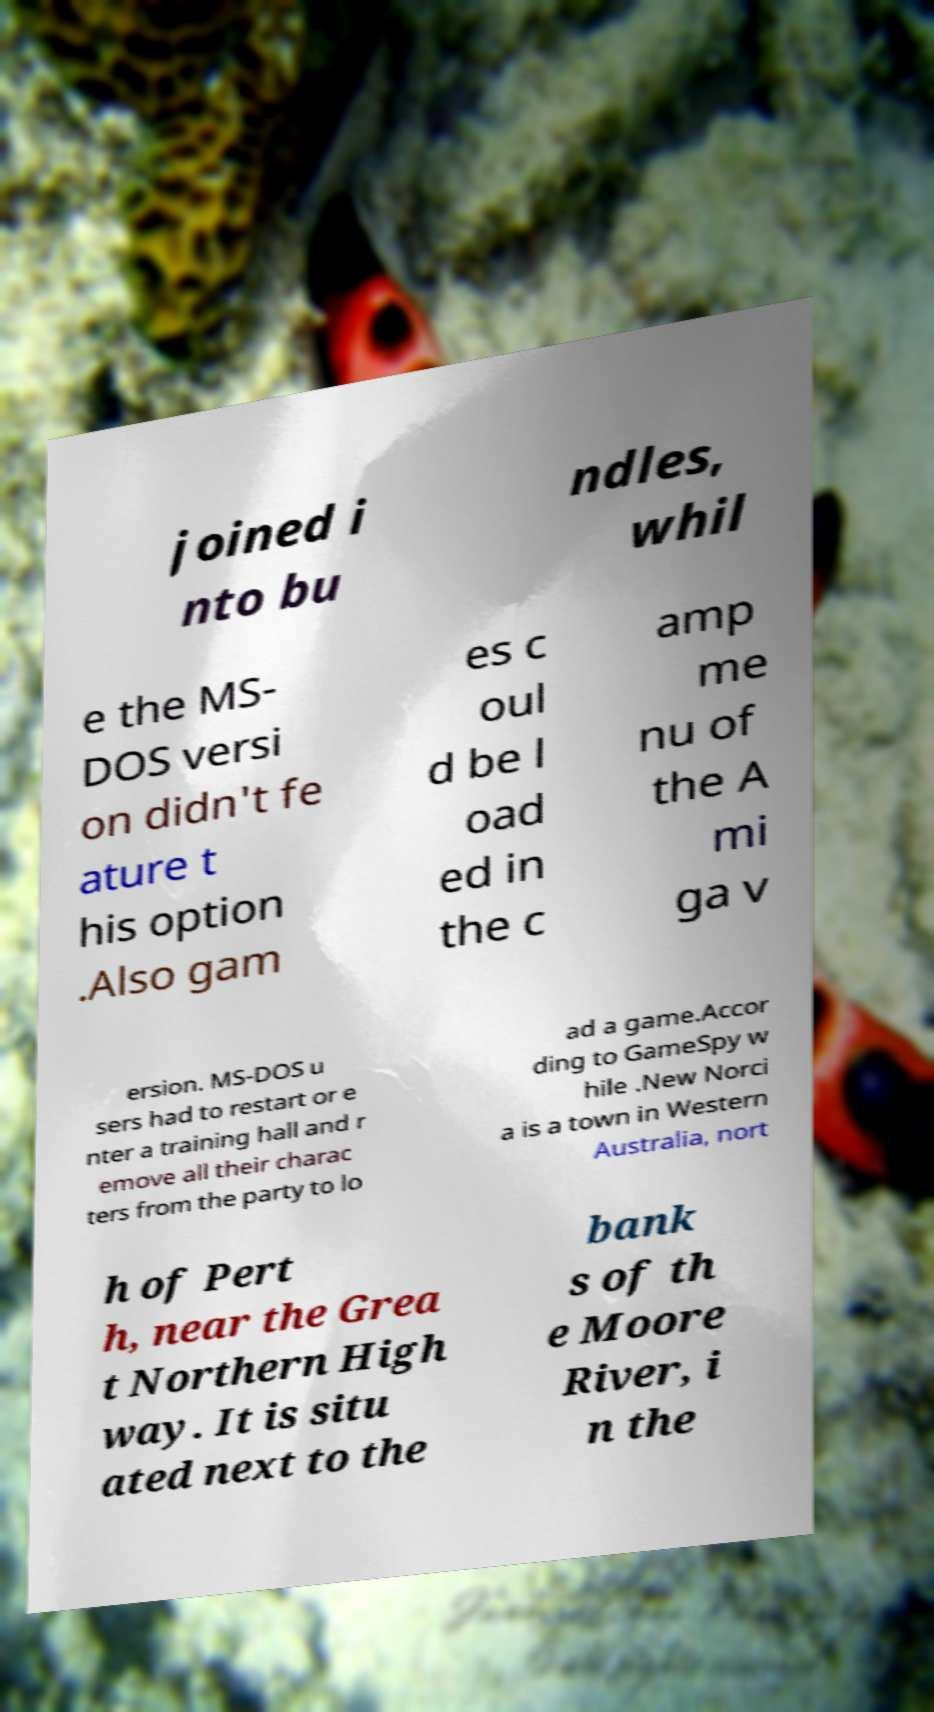Could you assist in decoding the text presented in this image and type it out clearly? joined i nto bu ndles, whil e the MS- DOS versi on didn't fe ature t his option .Also gam es c oul d be l oad ed in the c amp me nu of the A mi ga v ersion. MS-DOS u sers had to restart or e nter a training hall and r emove all their charac ters from the party to lo ad a game.Accor ding to GameSpy w hile .New Norci a is a town in Western Australia, nort h of Pert h, near the Grea t Northern High way. It is situ ated next to the bank s of th e Moore River, i n the 